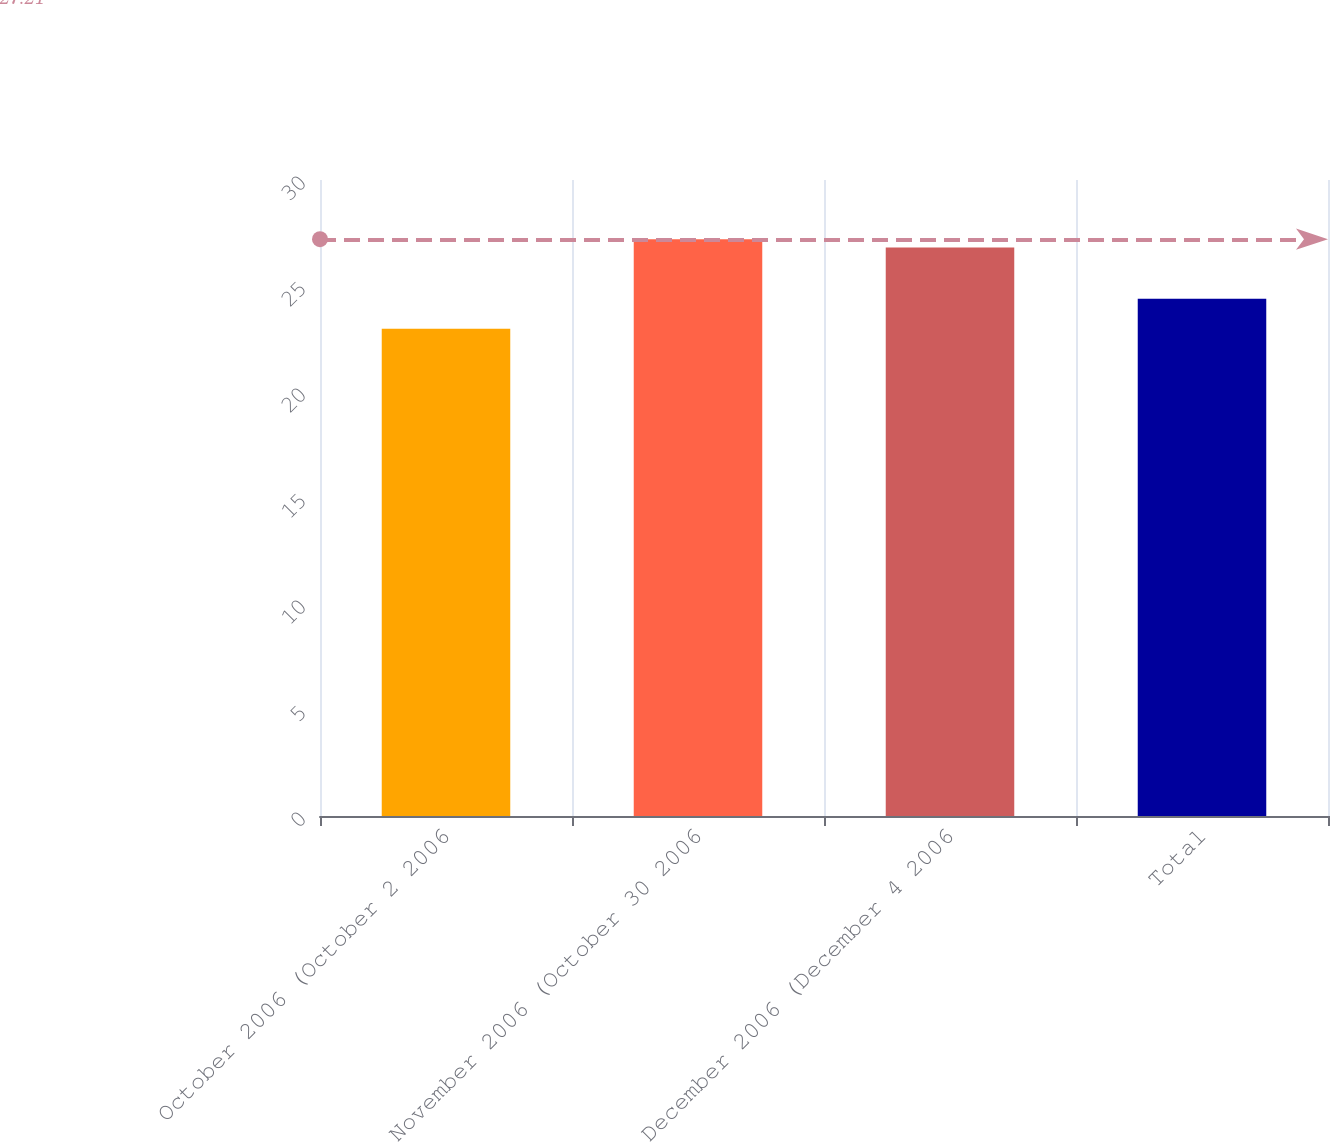Convert chart. <chart><loc_0><loc_0><loc_500><loc_500><bar_chart><fcel>October 2006 (October 2 2006<fcel>November 2006 (October 30 2006<fcel>December 2006 (December 4 2006<fcel>Total<nl><fcel>22.98<fcel>27.21<fcel>26.82<fcel>24.4<nl></chart> 